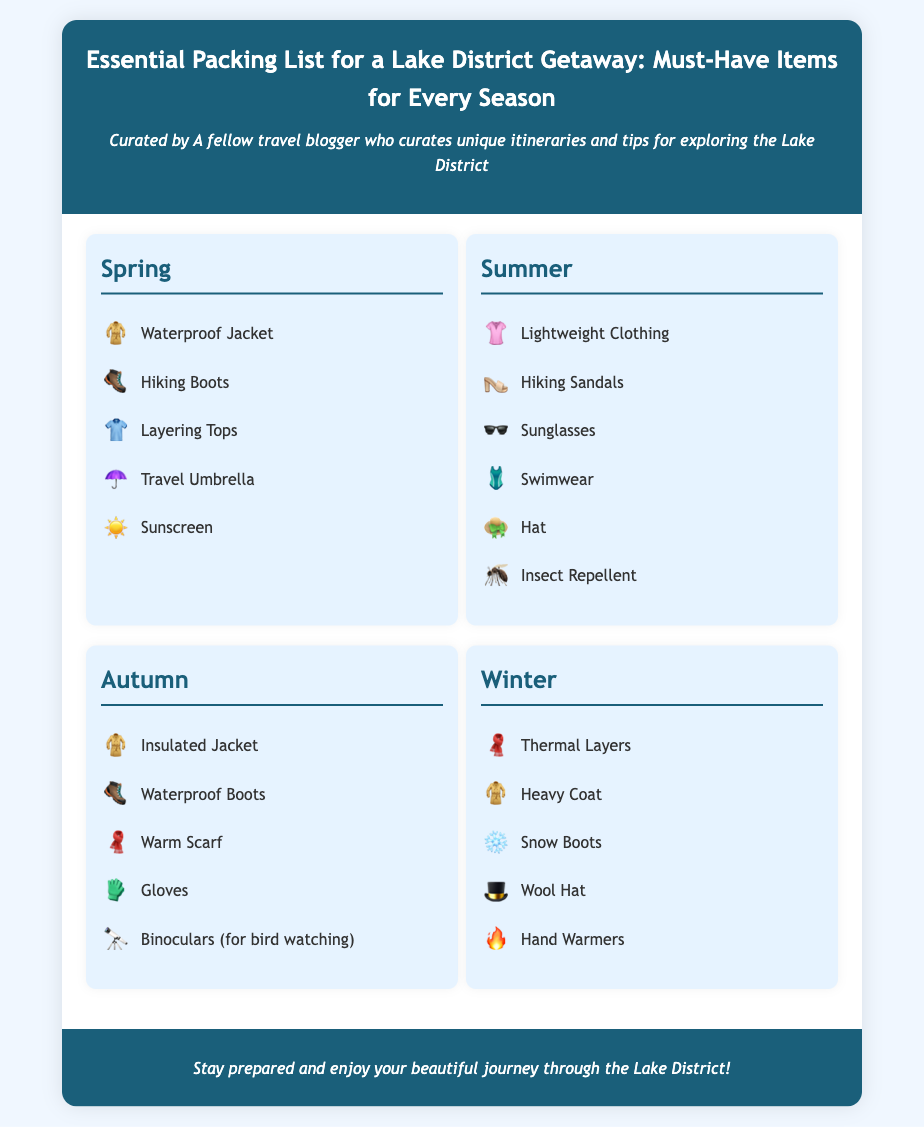What items are recommended for spring packing? The spring packing list includes a waterproof jacket, hiking boots, layering tops, travel umbrella, and sunscreen.
Answer: Waterproof jacket, hiking boots, layering tops, travel umbrella, sunscreen How many items are listed for summer? The summer packing list contains six items.
Answer: Six What is one item to pack for autumn bird watching? The autumn list includes binoculars specifically for bird watching.
Answer: Binoculars Which item is required in winter for warmth? The winter packing list suggests thermal layers to keep warm.
Answer: Thermal layers What type of footwear is suggested for autumn? The recommended footwear for autumn is waterproof boots.
Answer: Waterproof boots What is the primary document type of this content? This document is an infographic focused on essential packing lists.
Answer: Infographic Which season includes swimwear in the packing list? Swimwear is included in the summer packing list.
Answer: Summer What is the icon for insect repellent? The insect repellent is represented by the mosquito icon.
Answer: Mosquito How many seasons are covered in the packing list? The packing list covers four seasons: spring, summer, autumn, and winter.
Answer: Four 